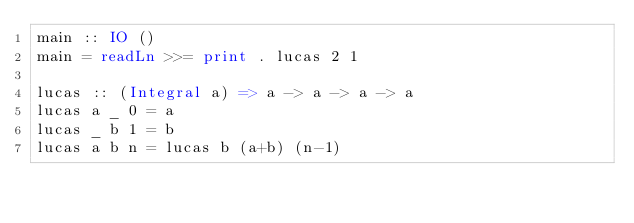<code> <loc_0><loc_0><loc_500><loc_500><_Haskell_>main :: IO ()                                                                                                              
main = readLn >>= print . lucas 2 1                                                                                        
                                                                                                                           
lucas :: (Integral a) => a -> a -> a -> a                                                                                  
lucas a _ 0 = a                                                                                                            
lucas _ b 1 = b                                                                                                            
lucas a b n = lucas b (a+b) (n-1)</code> 